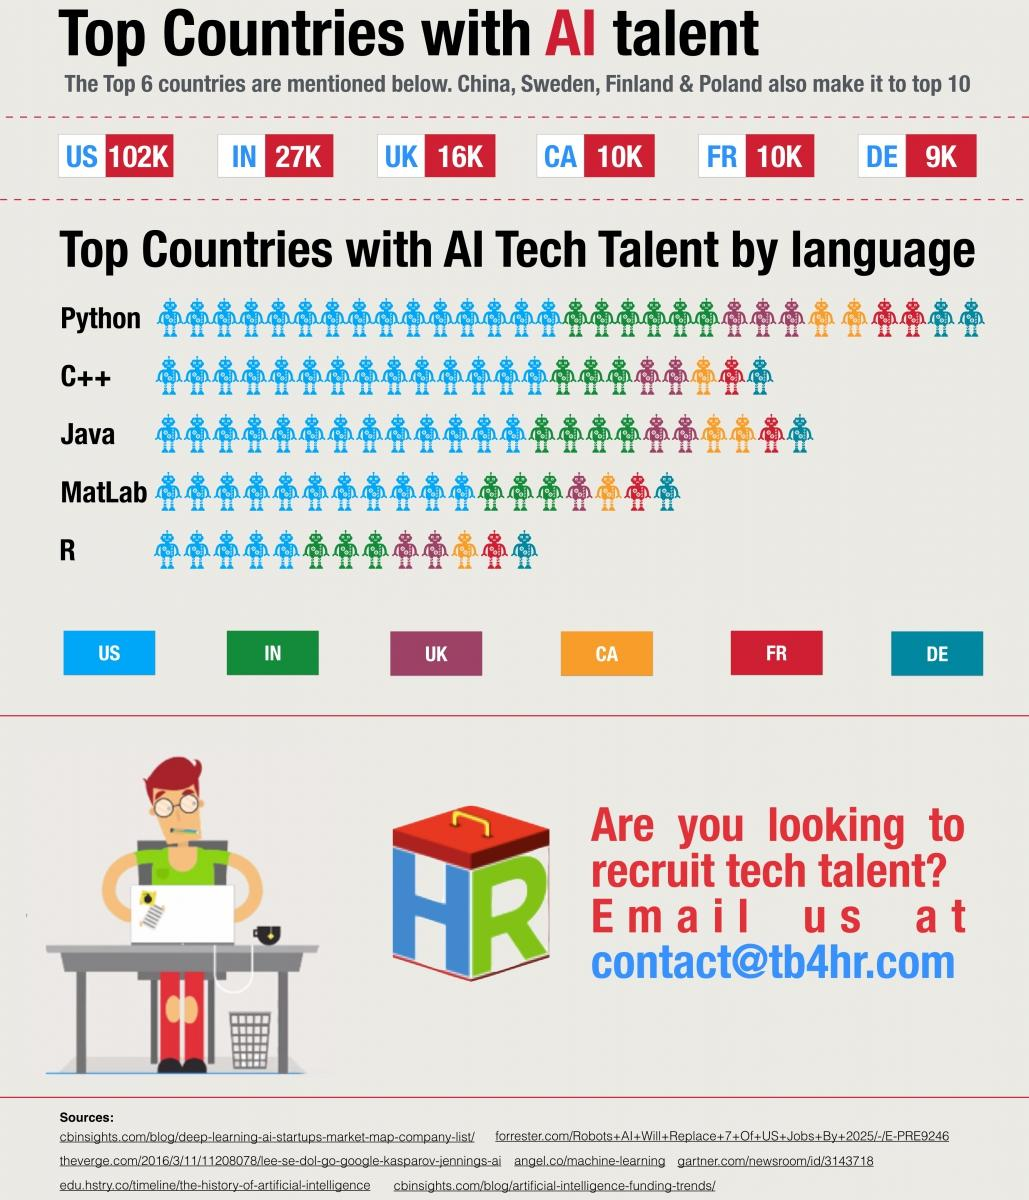Mention a couple of crucial points in this snapshot. Python is the most commonly used AI language in these countries. The United States is the country with the most advanced AI technology and talent. Denmark is the country that is least equipped with AI technology talent. The least used AI language in these countries is [R, S, T, U, V, W, X, Y, or Z]. 